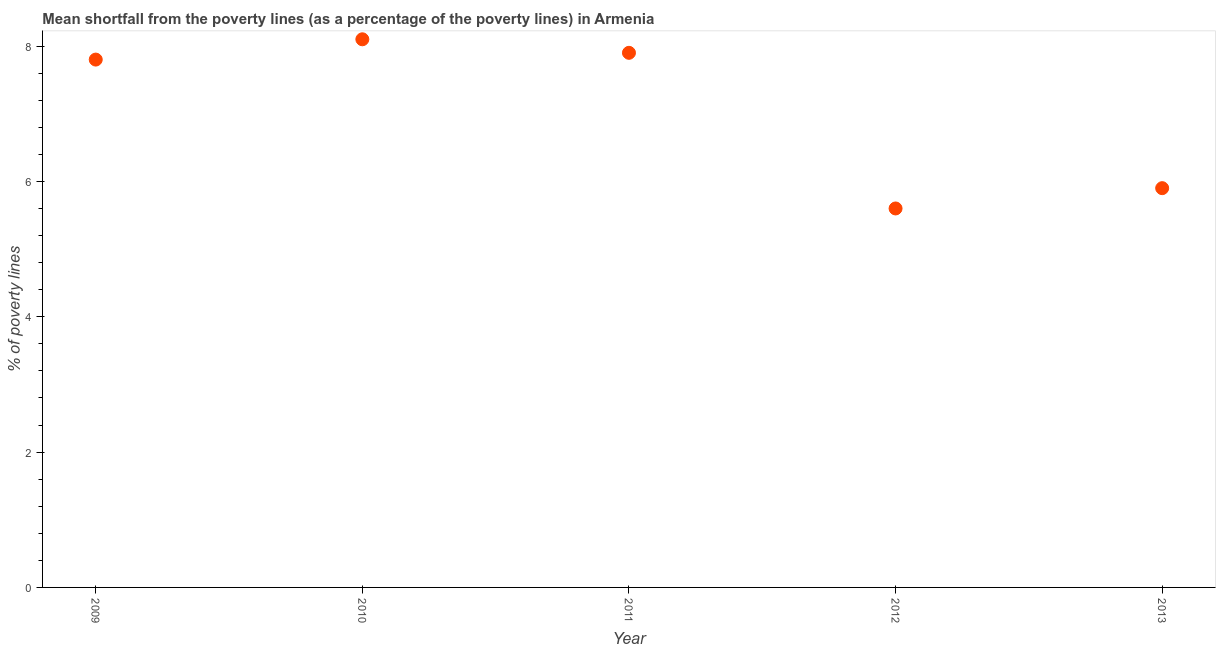What is the poverty gap at national poverty lines in 2009?
Keep it short and to the point. 7.8. Across all years, what is the minimum poverty gap at national poverty lines?
Your answer should be compact. 5.6. In which year was the poverty gap at national poverty lines minimum?
Keep it short and to the point. 2012. What is the sum of the poverty gap at national poverty lines?
Make the answer very short. 35.3. What is the average poverty gap at national poverty lines per year?
Your answer should be compact. 7.06. What is the median poverty gap at national poverty lines?
Ensure brevity in your answer.  7.8. In how many years, is the poverty gap at national poverty lines greater than 2.4 %?
Make the answer very short. 5. What is the ratio of the poverty gap at national poverty lines in 2009 to that in 2011?
Provide a short and direct response. 0.99. Is the poverty gap at national poverty lines in 2009 less than that in 2013?
Your response must be concise. No. What is the difference between the highest and the second highest poverty gap at national poverty lines?
Give a very brief answer. 0.2. Is the sum of the poverty gap at national poverty lines in 2011 and 2013 greater than the maximum poverty gap at national poverty lines across all years?
Your response must be concise. Yes. In how many years, is the poverty gap at national poverty lines greater than the average poverty gap at national poverty lines taken over all years?
Your response must be concise. 3. Does the graph contain any zero values?
Keep it short and to the point. No. What is the title of the graph?
Provide a short and direct response. Mean shortfall from the poverty lines (as a percentage of the poverty lines) in Armenia. What is the label or title of the Y-axis?
Your answer should be very brief. % of poverty lines. What is the % of poverty lines in 2009?
Your response must be concise. 7.8. What is the % of poverty lines in 2012?
Provide a succinct answer. 5.6. What is the difference between the % of poverty lines in 2009 and 2012?
Your answer should be compact. 2.2. What is the difference between the % of poverty lines in 2009 and 2013?
Provide a succinct answer. 1.9. What is the difference between the % of poverty lines in 2010 and 2011?
Offer a terse response. 0.2. What is the difference between the % of poverty lines in 2010 and 2012?
Your answer should be compact. 2.5. What is the difference between the % of poverty lines in 2010 and 2013?
Your answer should be very brief. 2.2. What is the difference between the % of poverty lines in 2011 and 2012?
Make the answer very short. 2.3. What is the ratio of the % of poverty lines in 2009 to that in 2010?
Keep it short and to the point. 0.96. What is the ratio of the % of poverty lines in 2009 to that in 2012?
Give a very brief answer. 1.39. What is the ratio of the % of poverty lines in 2009 to that in 2013?
Your answer should be very brief. 1.32. What is the ratio of the % of poverty lines in 2010 to that in 2011?
Your answer should be compact. 1.02. What is the ratio of the % of poverty lines in 2010 to that in 2012?
Your response must be concise. 1.45. What is the ratio of the % of poverty lines in 2010 to that in 2013?
Your answer should be very brief. 1.37. What is the ratio of the % of poverty lines in 2011 to that in 2012?
Offer a terse response. 1.41. What is the ratio of the % of poverty lines in 2011 to that in 2013?
Give a very brief answer. 1.34. What is the ratio of the % of poverty lines in 2012 to that in 2013?
Your answer should be compact. 0.95. 